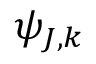Convert formula to latex. <formula><loc_0><loc_0><loc_500><loc_500>\psi _ { J , k }</formula> 